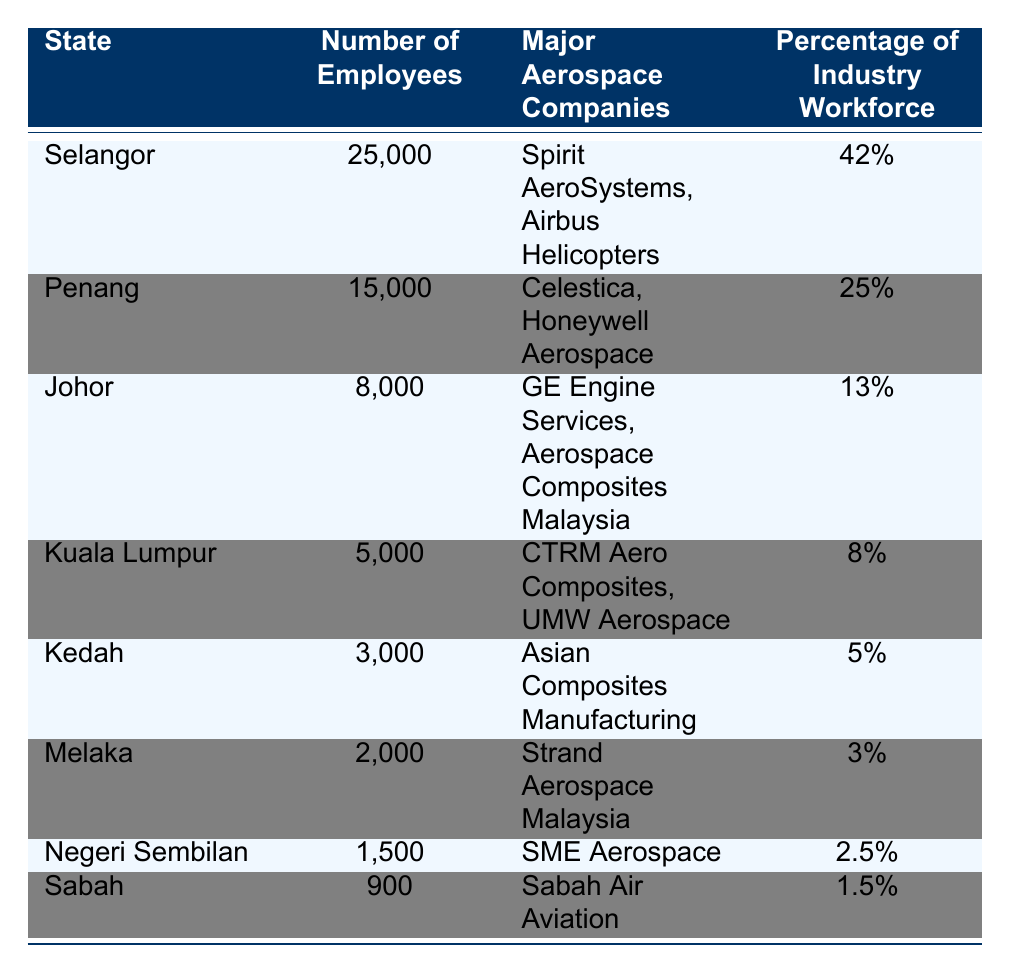What is the state with the largest number of aerospace employees? By looking at the table, Selangor has the highest number of employees at 25,000.
Answer: Selangor What percentage of the industry workforce does Penang represent? According to the table, Penang makes up 25% of the industry workforce.
Answer: 25% Is Johor one of the states with more than 10% of the industry workforce? Yes, Johor has 13% of the industry workforce, which is more than 10%.
Answer: Yes What is the total number of employees across all listed states? Adding up the employees: 25000 (Selangor) + 15000 (Penang) + 8000 (Johor) + 5000 (Kuala Lumpur) + 3000 (Kedah) + 2000 (Melaka) + 1500 (Negeri Sembilan) + 900 (Sabah) gives a total of 65,400.
Answer: 65400 Which state has the smallest aerospace workforce? The smallest number of employees is in Sabah, with only 900 employees.
Answer: Sabah What are the major aerospace companies in Kedah? The table lists Asian Composites Manufacturing as the major aerospace company in Kedah.
Answer: Asian Composites Manufacturing What is the combined percentage of the industry workforce for Selangor and Penang? Adding the percentages: 42% (Selangor) + 25% (Penang) equals 67%.
Answer: 67% Does Negeri Sembilan have more employees than Melaka? Yes, Negeri Sembilan has 1,500 employees while Melaka has only 2,000 employees.
Answer: No 